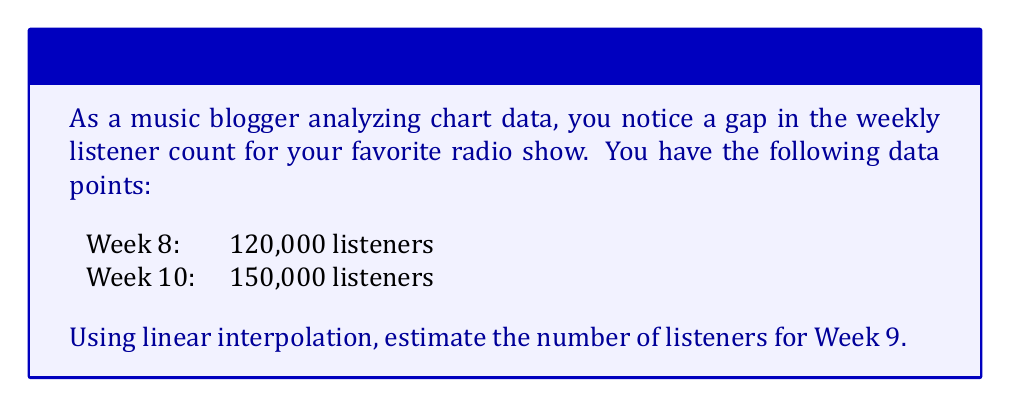Show me your answer to this math problem. To solve this problem using linear interpolation, we'll follow these steps:

1) Let's define our variables:
   $x_1 = 8$, $y_1 = 120,000$ (Week 8 data)
   $x_2 = 10$, $y_2 = 150,000$ (Week 10 data)
   $x = 9$ (Week 9, the point we're estimating)

2) The formula for linear interpolation is:

   $$ y = y_1 + \frac{(x - x_1)(y_2 - y_1)}{(x_2 - x_1)} $$

3) Let's substitute our values:

   $$ y = 120,000 + \frac{(9 - 8)(150,000 - 120,000)}{(10 - 8)} $$

4) Simplify:

   $$ y = 120,000 + \frac{1 \times 30,000}{2} $$

5) Calculate:

   $$ y = 120,000 + 15,000 = 135,000 $$

Therefore, the estimated number of listeners for Week 9 is 135,000.
Answer: 135,000 listeners 